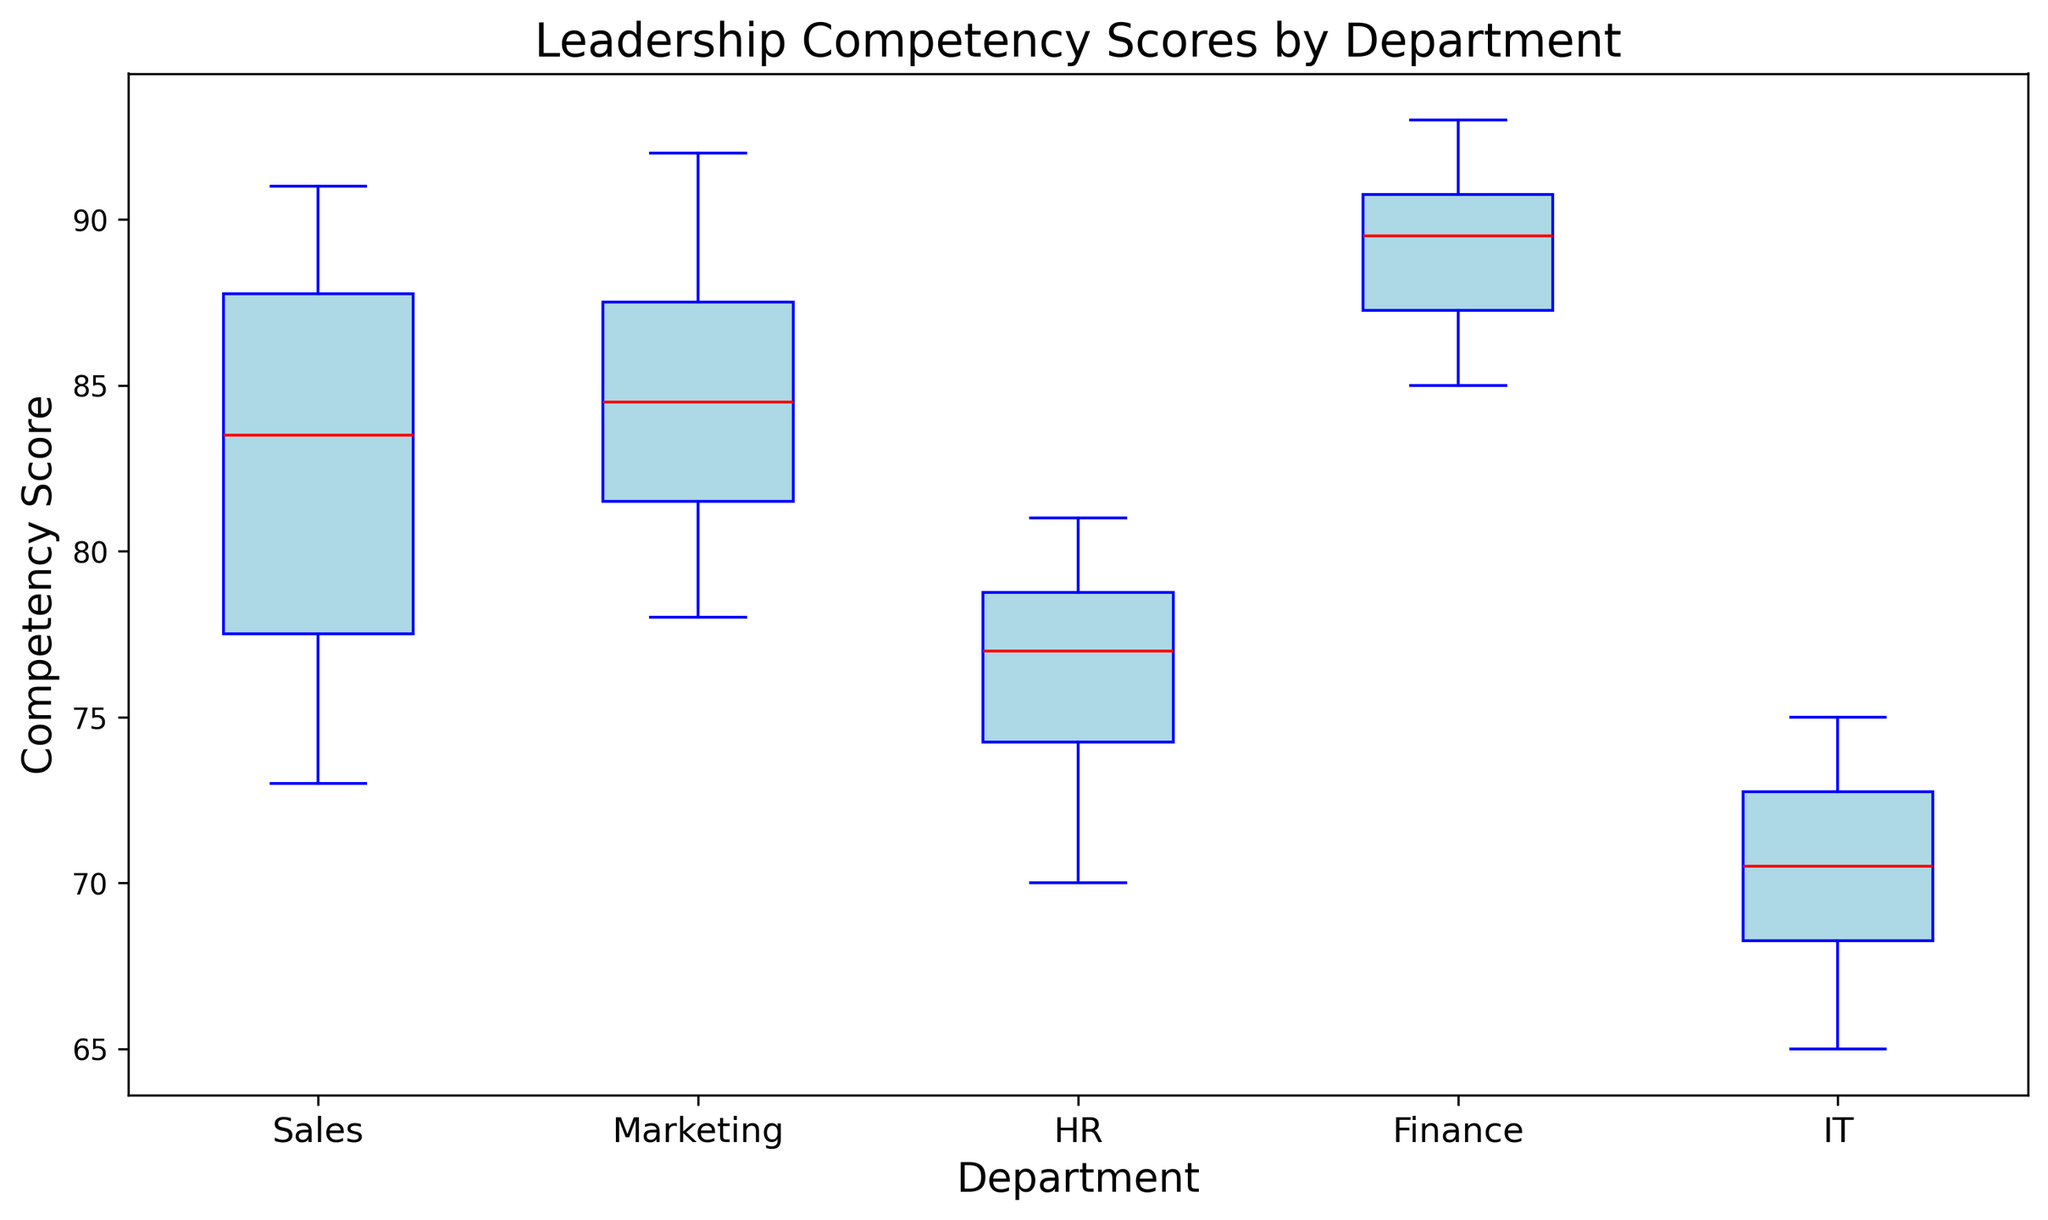What is the median Leadership Competency Score for the Sales department? Look for the median line within the Sales department's box in the plot. The median is denoted by the red line inside the box.
Answer: 85 Which department has the highest maximum Leadership Competency Score? Check the top whisker of each box plot to find the highest value. The whisker representing the max value is highest for the Marketing department.
Answer: Marketing Among all departments, which has the lowest median Leadership Competency Score? Compare the red median lines across all departments' box plots; the IT department's median is lowest.
Answer: IT How does the interquartile range (IQR) of the HR department compare to that of the Sales department? The IQR is the height of the box from the lower quartile to the upper quartile. Compare the height of the boxes for HR and Sales.
Answer: HR is smaller What is the range of Leadership Competency Scores in the IT department? The range is the difference between the maximum and minimum values represented by the whiskers of the IT department's box plot.
Answer: 65 to 75 Which department has the widest spread in Leadership Competency Scores? Identify the department with the tallest box and longest whiskers, indicating the largest spread. The Finance department has a noticeable spread.
Answer: Finance Do any departments have outliers, and if so, which ones? Outliers are represented by green markers outside of the whiskers, check each department for these markers. No department shows green markers, thus no outliers.
Answer: None Compare the median Leadership Competency Scores between the Marketing and HR departments. Identify the red median lines within both departments' boxes and compare their positions. The Marketing median line is above the HR median line.
Answer: Marketing > HR Which department's Leadership Competency Scores are most consistently high? Look at the overall heights and spreads of the boxes; Finance strikes a balance with high scores and a moderate range.
Answer: Finance Is there a department where all scores fall within a narrower range compared to others? Compare the width of the boxes and the lengths of whiskers; HR has a narrow range with all scores close to the median.
Answer: HR 